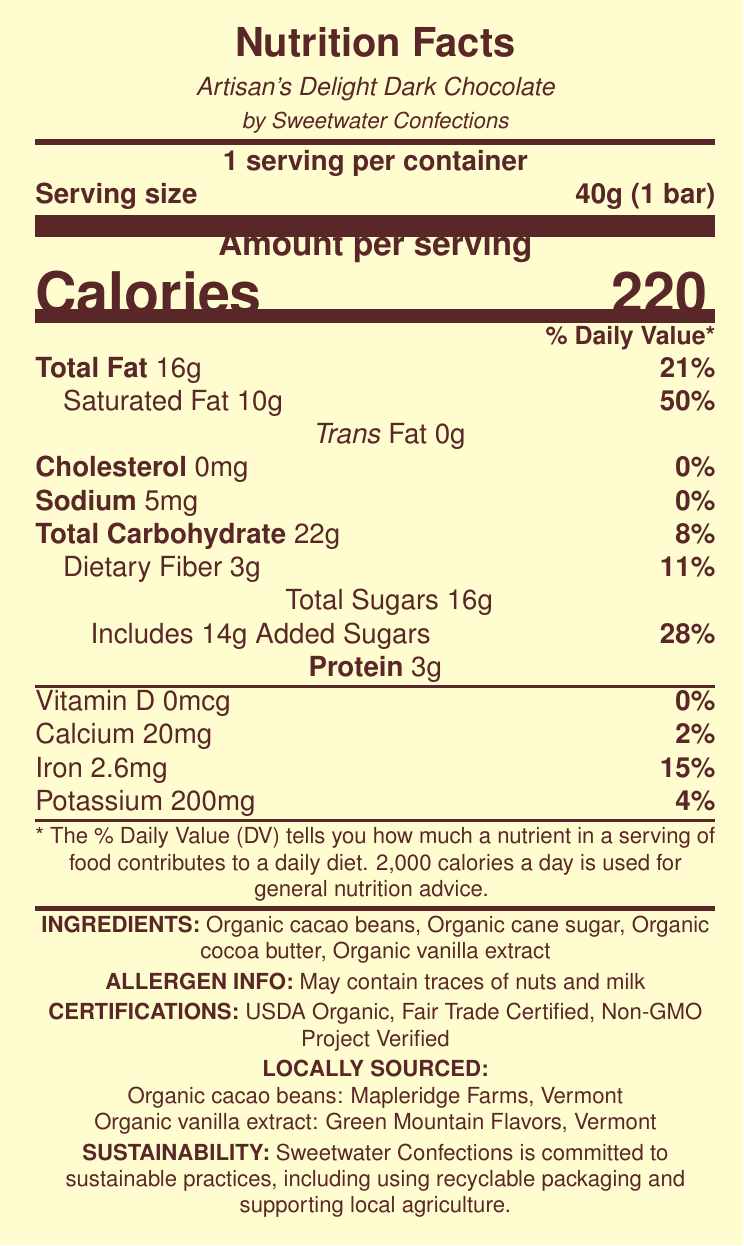what is the serving size for Artisan's Delight Dark Chocolate? The serving size is explicitly mentioned as "40g (1 bar)" in the document.
Answer: 40g (1 bar) how many calories are in one serving? The document states the calories per serving as 220.
Answer: 220 how much saturated fat is in one serving and what percent of the daily value does it represent? The document lists saturated fat as 10g and its daily value percentage as 50%.
Answer: 10g, 50% what are the ingredients in Artisan's Delight Dark Chocolate? The ingredients are listed in the document.
Answer: Organic cacao beans, Organic cane sugar, Organic cocoa butter, Organic vanilla extract what certifications does Artisan's Delight Dark Chocolate have? The certifications are mentioned at the bottom of the document.
Answer: USDA Organic, Fair Trade Certified, Non-GMO Project Verified which local source provides the organic cacao beans? A. Sweet Hills Farms B. Mapleridge Farms, Vermont C. Green Mountain Flavors, Vermont D. Local Beans Co. The organic cacao beans are sourced from Mapleridge Farms, Vermont.
Answer: B what is the serving size of the chocolate bar? A. 50g B. 30g C. 40g D. 45g The serving size is listed as 40g (1 bar).
Answer: C does this product contain any trans fat? The document states "Trans Fat 0g" indicating it contains no trans fat.
Answer: No is the provided Nutrition Facts Label for a product by Sweetwater Confections? The label states that Artisan's Delight Dark Chocolate is by Sweetwater Confections.
Answer: Yes describe the main idea of the Nutrition Facts Label for Artisan's Delight Dark Chocolate bar. The label includes nutritional data with percentages of daily values, a list of organic ingredients, mentions local sources, and outlines the company's commitment to sustainability through certifications and practices.
Answer: The Nutrition Facts Label for Artisan's Delight Dark Chocolate by Sweetwater Confections provides nutritional information per 40g serving, ingredient details, allergen information, certifications, and sources of locally-sourced ingredients while highlighting sustainable practices. what are the allergen warnings for this product? The allergen info section of the document specifies that it may contain traces of nuts and milk.
Answer: May contain traces of nuts and milk how much calcium is present in one serving, and what percentage of the daily value does this represent? The calcium content is listed as 20mg and 2% of the daily value.
Answer: 20mg, 2% which small business tax credits does Sweetwater Confections qualify for? The tax credits are mentioned in the document under small business tax credits.
Answer: Work Opportunity Tax Credit, Research and Development Tax Credit, Small Business Health Care Tax Credit from which source is the organic vanilla extract in the chocolate bar obtained? The locally-sourced ingredients section mentions that the organic vanilla extract is from Green Mountain Flavors, Vermont.
Answer: Green Mountain Flavors, Vermont does the product contain added sugars? If yes, how many grams and what percentage of the daily value does it represent? The document specifies 14g of added sugars, which is 28% of the daily value.
Answer: Yes, 14g, 28% are there any fiber contents in this chocolate bar? If so, how much? The document lists dietary fiber at 3g per serving.
Answer: Yes, 3g what SBA resources are available for Sweetwater Confections? A. SBA Learning Center and SCORE Mentoring B. SBA Learning Center and Community Grants C. SCORE Mentoring and Local Partnerships D. Research Grants and Tax Assistance The resources listed are the SBA Learning Center and SCORE Mentoring.
Answer: A what is the percentage of the daily value for iron in one serving of this chocolate bar? The document states that one serving contains 2.6mg of iron, which is 15% of the daily value.
Answer: 15% how much protein does one serving of Artisan's Delight Dark Chocolate contain? The protein content per serving is listed as 3g.
Answer: 3g why is the Research and Development Tax Credit relevant to Sweetwater Confections? The document explains that the Research and Development Tax Credit is for developing new chocolate recipes and production methods.
Answer: For developing new chocolate recipes and production methods what is the expiration date of the Artisan's Delight Dark Chocolate bar? The document does not provide information about the expiration date.
Answer: Cannot be determined 